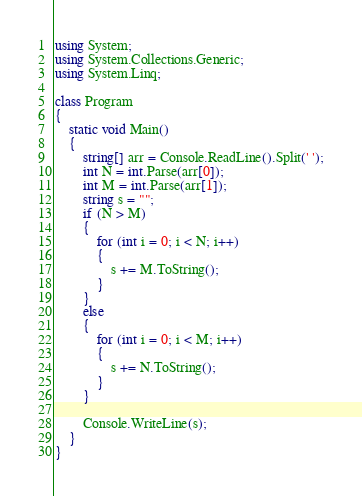Convert code to text. <code><loc_0><loc_0><loc_500><loc_500><_C#_>using System;
using System.Collections.Generic;
using System.Linq;

class Program
{
    static void Main()
    {
        string[] arr = Console.ReadLine().Split(' ');
        int N = int.Parse(arr[0]);
        int M = int.Parse(arr[1]);
        string s = "";
        if (N > M)
        {
            for (int i = 0; i < N; i++)
            {
                s += M.ToString();
            }
        }
        else
        {
            for (int i = 0; i < M; i++)
            {
                s += N.ToString();
            }
        }

        Console.WriteLine(s);
    }
}</code> 